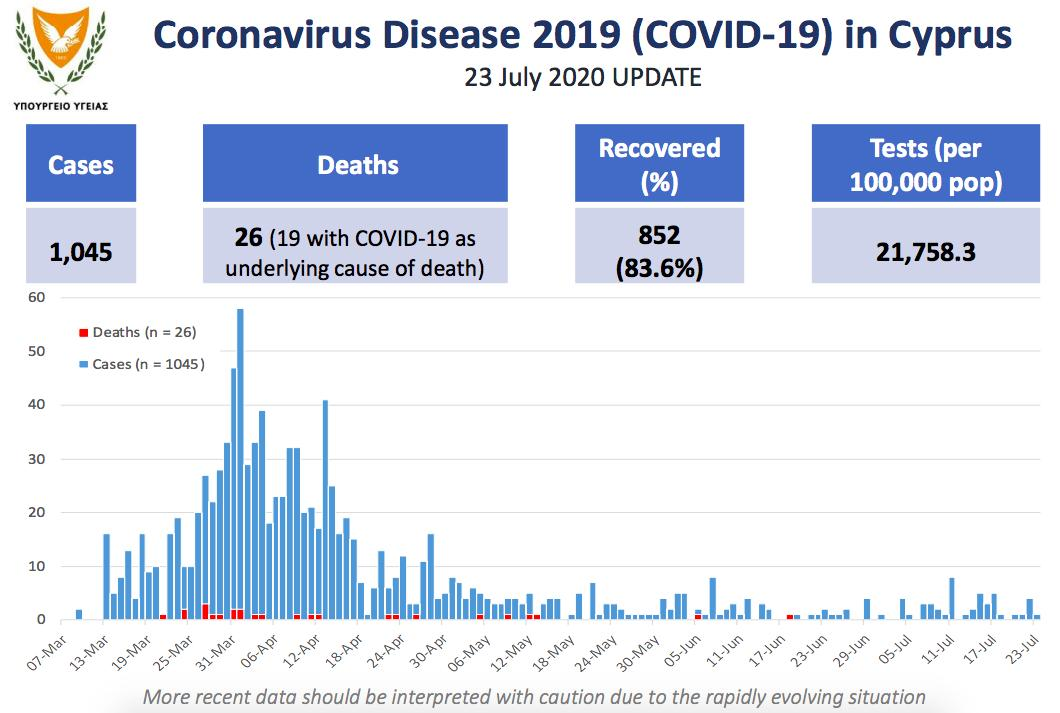Specify some key components in this picture. The first COVID-19 case was reported in Cyprus during the week of March 7th to March 13th. On March 27th, the day with the highest number of recorded deaths was observed. On June 19th, the number of reported cases was. On March 14th, there was a significant increase in COVID-19 cases in Cyprus, compared to the previous days. As of the last 3 days, there have only been reports of deaths and no new cases. 